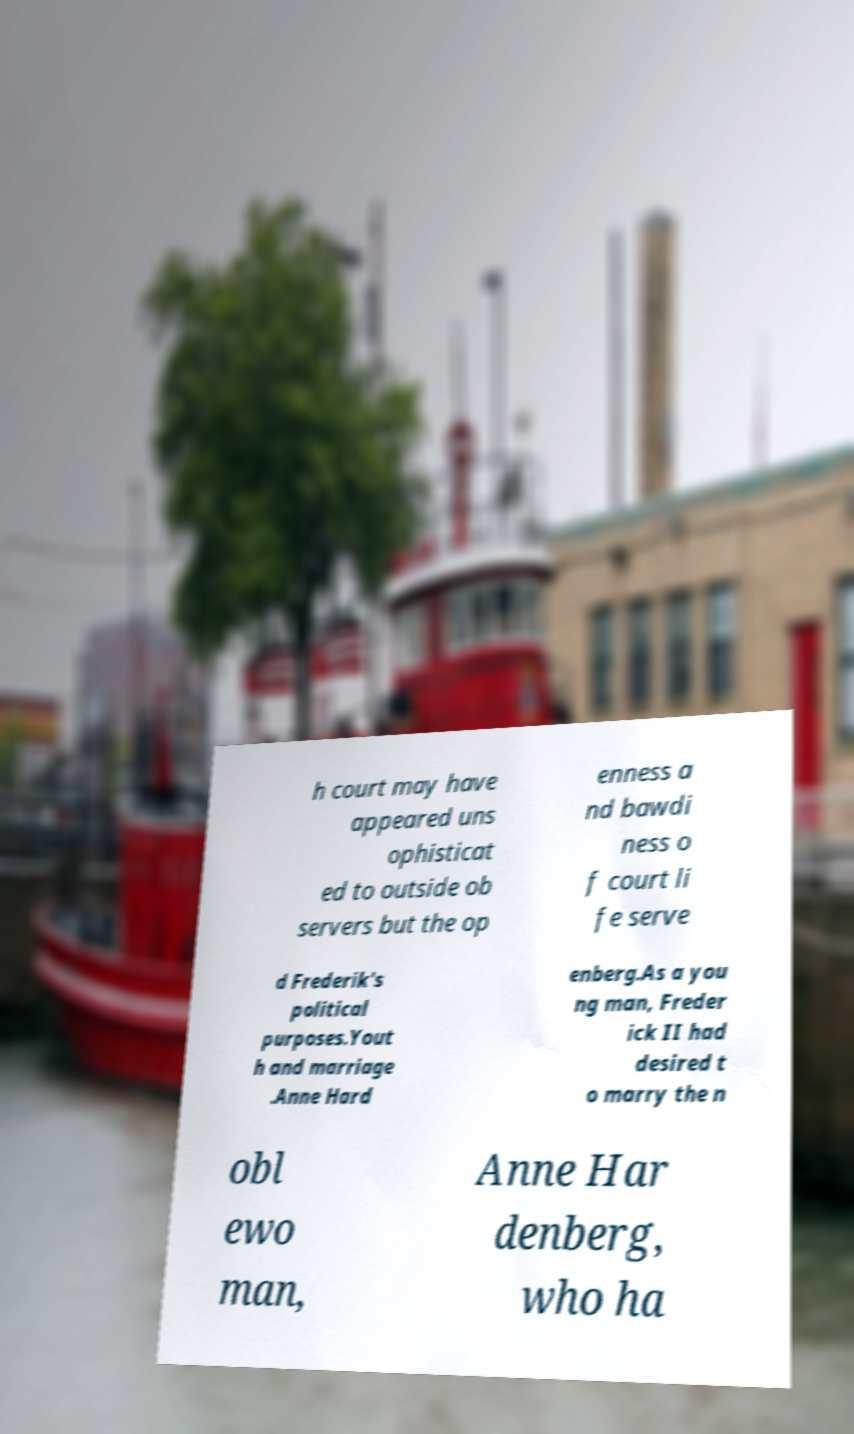Please identify and transcribe the text found in this image. h court may have appeared uns ophisticat ed to outside ob servers but the op enness a nd bawdi ness o f court li fe serve d Frederik's political purposes.Yout h and marriage .Anne Hard enberg.As a you ng man, Freder ick II had desired t o marry the n obl ewo man, Anne Har denberg, who ha 